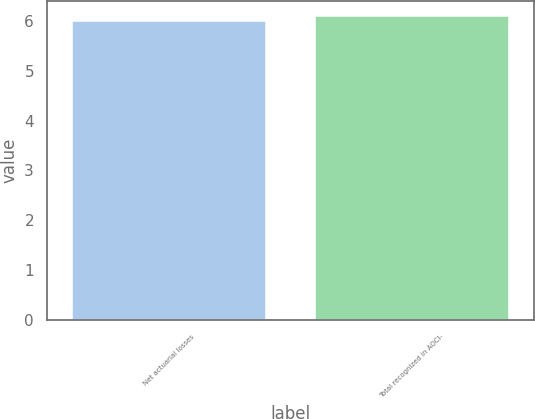Convert chart to OTSL. <chart><loc_0><loc_0><loc_500><loc_500><bar_chart><fcel>Net actuarial losses<fcel>Total recognized in AOCI-<nl><fcel>6<fcel>6.1<nl></chart> 